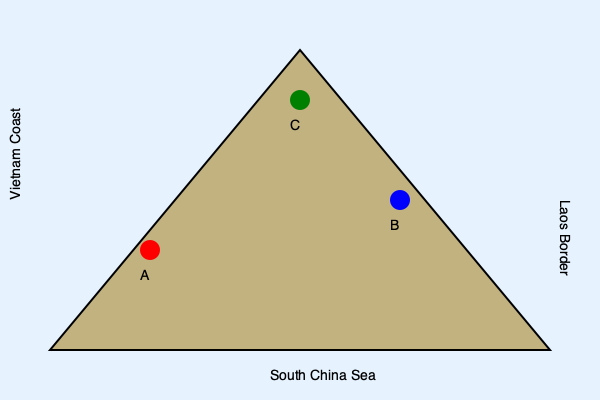In Marc Liebman's Josh Haman series, particularly in "Cherubs 2," which location marked on the map corresponds to the site where Josh Haman's helicopter was shot down during a mission to extract a team of SEALs? To answer this question, we need to recall key events from "Cherubs 2" in Marc Liebman's Josh Haman series:

1. The map shows three locations (A, B, and C) in relation to the South China Sea, Vietnam Coast, and Laos Border.

2. In "Cherubs 2," Josh Haman is piloting a helicopter on a mission to extract a team of SEALs.

3. The mission takes place near the Vietnamese-Laotian border, which is a crucial detail for locating the incident on the map.

4. During this mission, Josh's helicopter is shot down by enemy fire.

5. Looking at the map, we can see that point C is closest to the Laos Border, which aligns with the mission's location as described in the book.

6. Points A and B are further away from the Laos Border and closer to the coast, making them less likely to be the correct location for this particular incident.

Therefore, based on the geographical information provided in the book and the map, point C is the most likely location for where Josh Haman's helicopter was shot down during the SEAL extraction mission.
Answer: C 